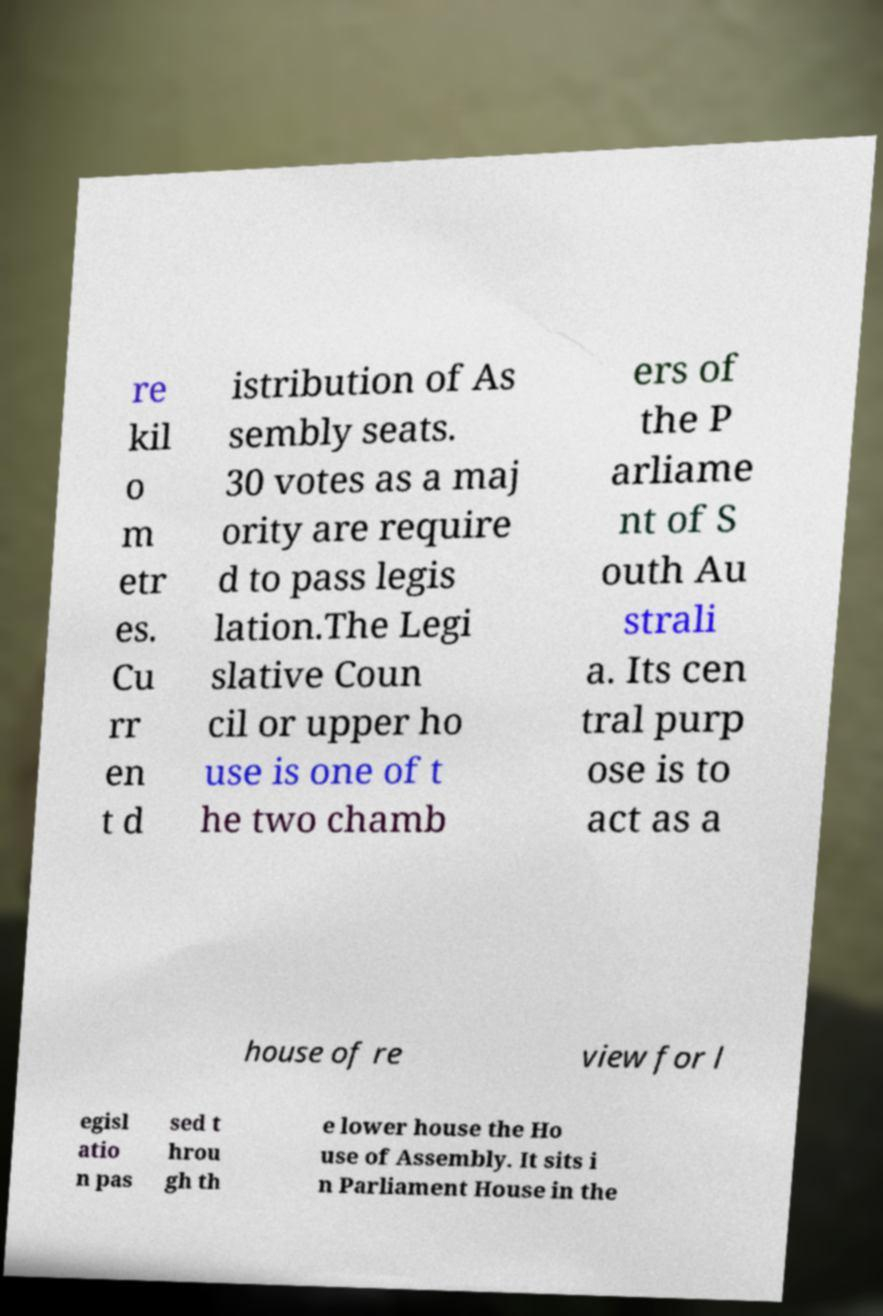Can you read and provide the text displayed in the image?This photo seems to have some interesting text. Can you extract and type it out for me? re kil o m etr es. Cu rr en t d istribution of As sembly seats. 30 votes as a maj ority are require d to pass legis lation.The Legi slative Coun cil or upper ho use is one of t he two chamb ers of the P arliame nt of S outh Au strali a. Its cen tral purp ose is to act as a house of re view for l egisl atio n pas sed t hrou gh th e lower house the Ho use of Assembly. It sits i n Parliament House in the 